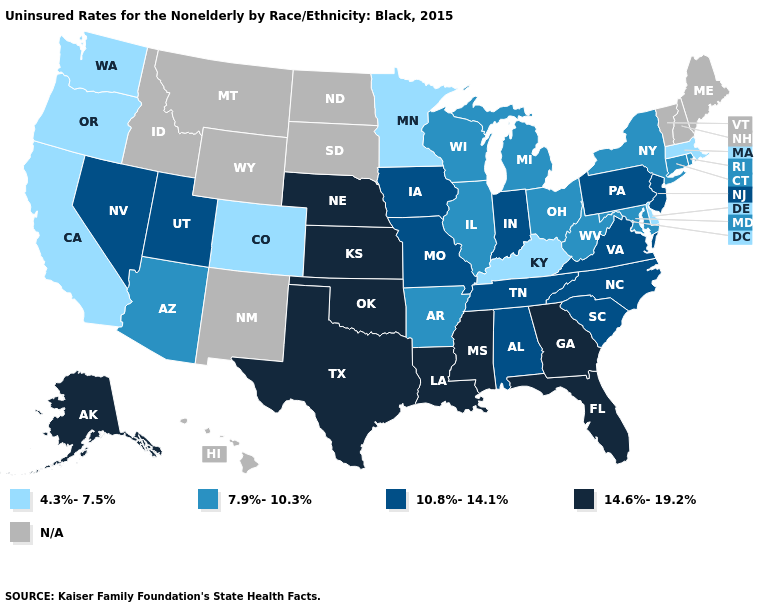Which states have the lowest value in the South?
Quick response, please. Delaware, Kentucky. What is the highest value in states that border West Virginia?
Write a very short answer. 10.8%-14.1%. What is the value of Connecticut?
Short answer required. 7.9%-10.3%. Name the states that have a value in the range 7.9%-10.3%?
Write a very short answer. Arizona, Arkansas, Connecticut, Illinois, Maryland, Michigan, New York, Ohio, Rhode Island, West Virginia, Wisconsin. Name the states that have a value in the range N/A?
Concise answer only. Hawaii, Idaho, Maine, Montana, New Hampshire, New Mexico, North Dakota, South Dakota, Vermont, Wyoming. Is the legend a continuous bar?
Be succinct. No. What is the value of Indiana?
Short answer required. 10.8%-14.1%. What is the value of Washington?
Quick response, please. 4.3%-7.5%. Name the states that have a value in the range 10.8%-14.1%?
Keep it brief. Alabama, Indiana, Iowa, Missouri, Nevada, New Jersey, North Carolina, Pennsylvania, South Carolina, Tennessee, Utah, Virginia. What is the highest value in states that border West Virginia?
Concise answer only. 10.8%-14.1%. Which states have the highest value in the USA?
Answer briefly. Alaska, Florida, Georgia, Kansas, Louisiana, Mississippi, Nebraska, Oklahoma, Texas. Does the first symbol in the legend represent the smallest category?
Answer briefly. Yes. Name the states that have a value in the range 4.3%-7.5%?
Give a very brief answer. California, Colorado, Delaware, Kentucky, Massachusetts, Minnesota, Oregon, Washington. Does California have the lowest value in the USA?
Short answer required. Yes. Does the first symbol in the legend represent the smallest category?
Give a very brief answer. Yes. 